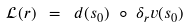<formula> <loc_0><loc_0><loc_500><loc_500>\mathcal { L } ( r ) \ = \ d ( s _ { 0 } ) \ \circ \ \delta _ { r } v ( s _ { 0 } )</formula> 